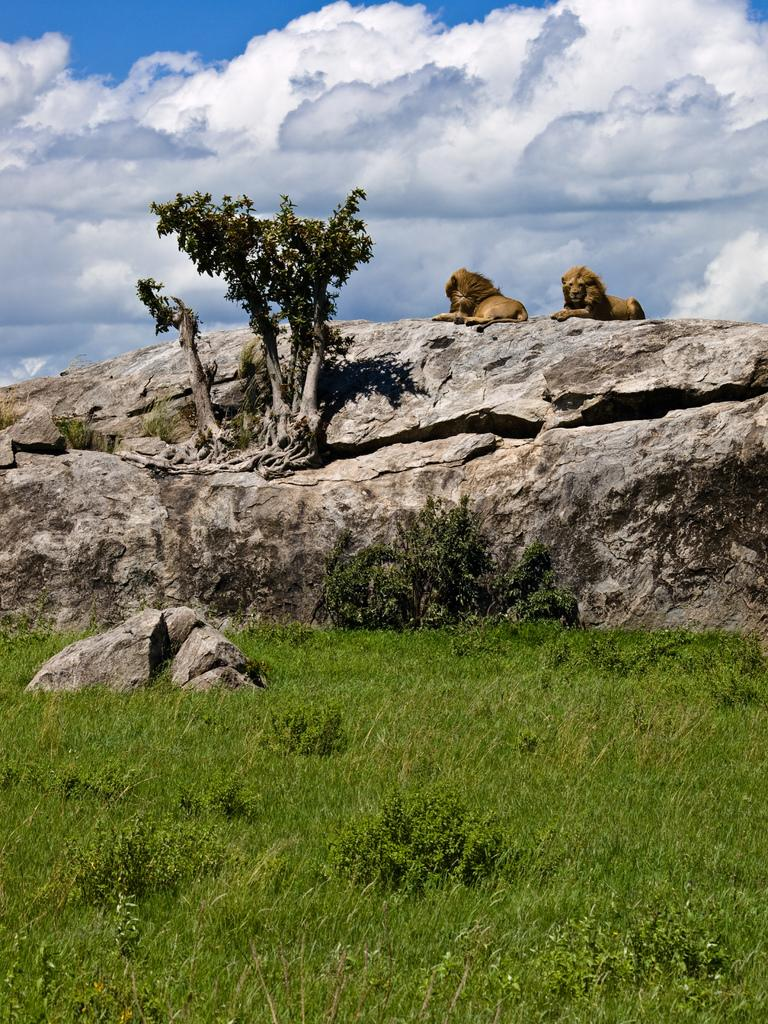How many lions are in the image? There are two lions in the image. What are the lions doing in the image? The lions are sitting on a rock. What is located beside the rock? There is a small tree beside the rock. What type of vegetation covers the ground in front of the rock? The ground in front of the rock is covered with grass. How much money is the lion holding in its paw in the image? There is no money visible in the image; the lions are sitting on a rock with a small tree beside it and grass-covered ground in front of the rock. 